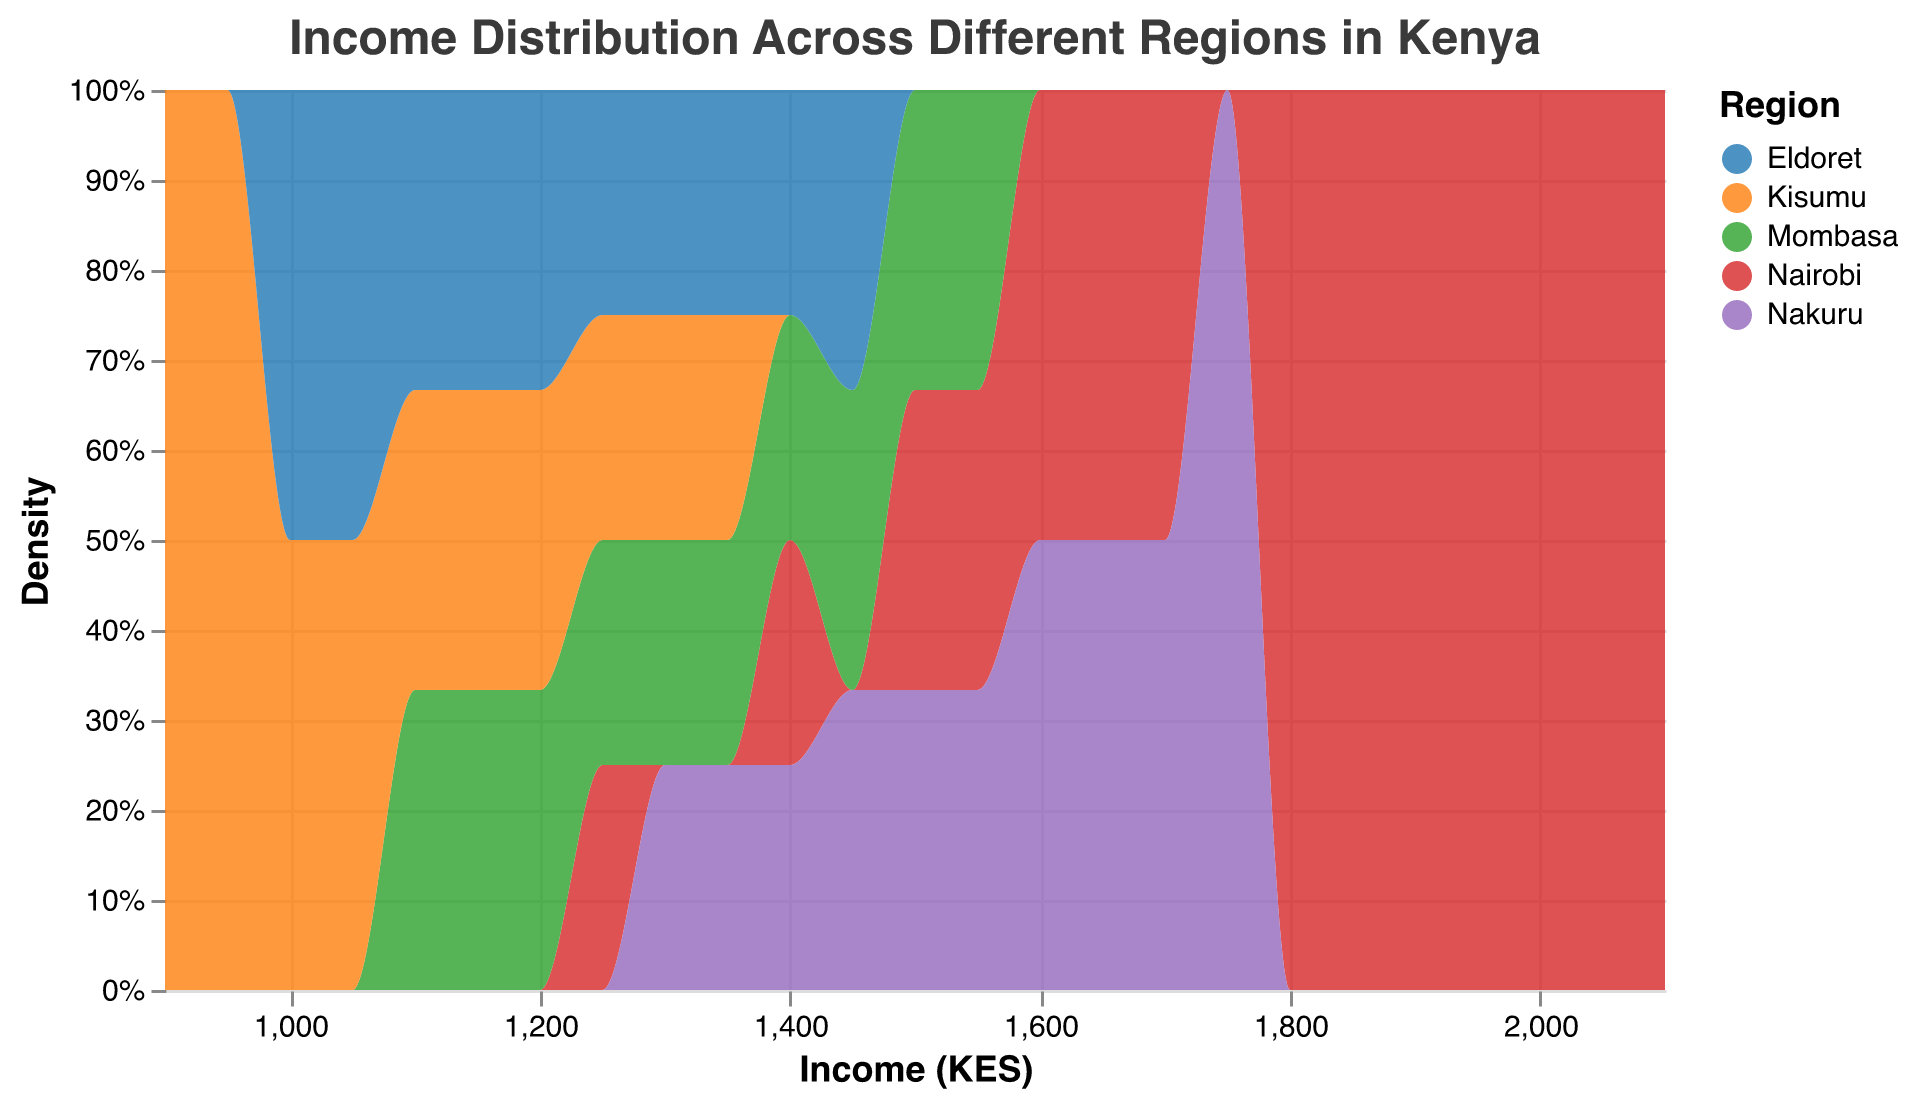What is the title of the density plot? The title usually appears at the top of the plot and it describes the content being visualized. It provides a quick context to the viewer.
Answer: Income Distribution Across Different Regions in Kenya Which region shows the highest income density? By observing the peaks of the density curves, the region with the highest peak has the highest income density.
Answer: Nairobi What is the income range for Mombasa? The income range can be identified by looking at the spread of the density curve for Mombasa on the x-axis.
Answer: 1100 - 1550 KES Which region has the broadest income distribution? The spread of the density curve on the x-axis indicates the range of income distribution. The region with the widest spread has the broadest income distribution.
Answer: Nairobi What's the average income for Eldoret? First, list the incomes for Eldoret: 1000, 1050, 1100, 1150, 1200, 1250, 1300, 1350, 1400, 1450. Sum these values: 11200. Divide by the number of data points (10).
Answer: 1120 KES Compare the income densities between Nairobi and Kisumu. Which region shows greater income inequality? Greater income inequality is indicated by a wider spread in the density curve. Nairobi has a broader spread compared to Kisumu, indicating higher inequality.
Answer: Nairobi Is there an income value that all regions have in common? Look for an income value where density curves for all regions overlap. Check the x-axis for such a point.
Answer: 1250 KES What is the highest income value represented in the plot? The highest income value is found by looking at the far right end of the x-axis.
Answer: 2100 KES Which region has the least variation in income? The region with the narrowest density curve, indicating less variation in income, shows the least variation.
Answer: Eldoret How does the income distribution in Nakuru compare to that in Mombasa? Compare the spread and overlapping areas of the density curves for Nakuru and Mombasa, focusing on the x-axis. Nakuru has a higher income range and more spread out incomes.
Answer: Nakuru has a broader distribution 